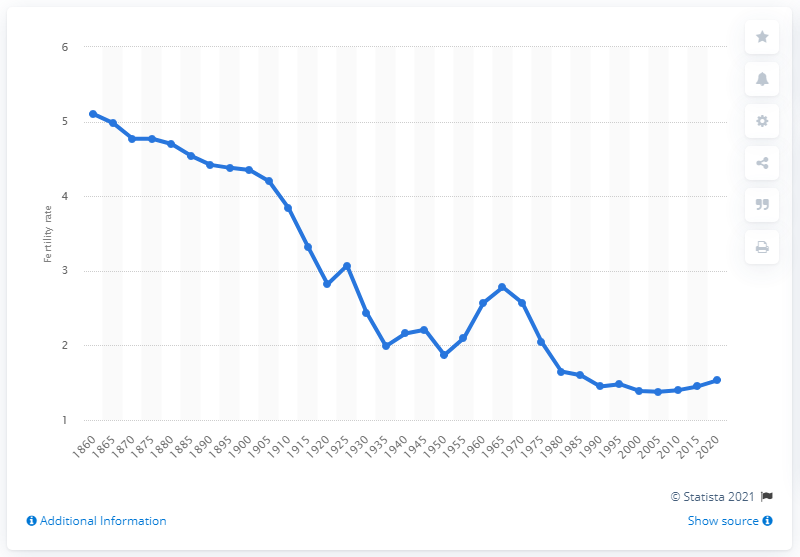Specify some key components in this picture. In 1935, Austria's fertility rate fell below two births per woman. In the year 1860, the fertility rate in Austria was just over five children per woman. 